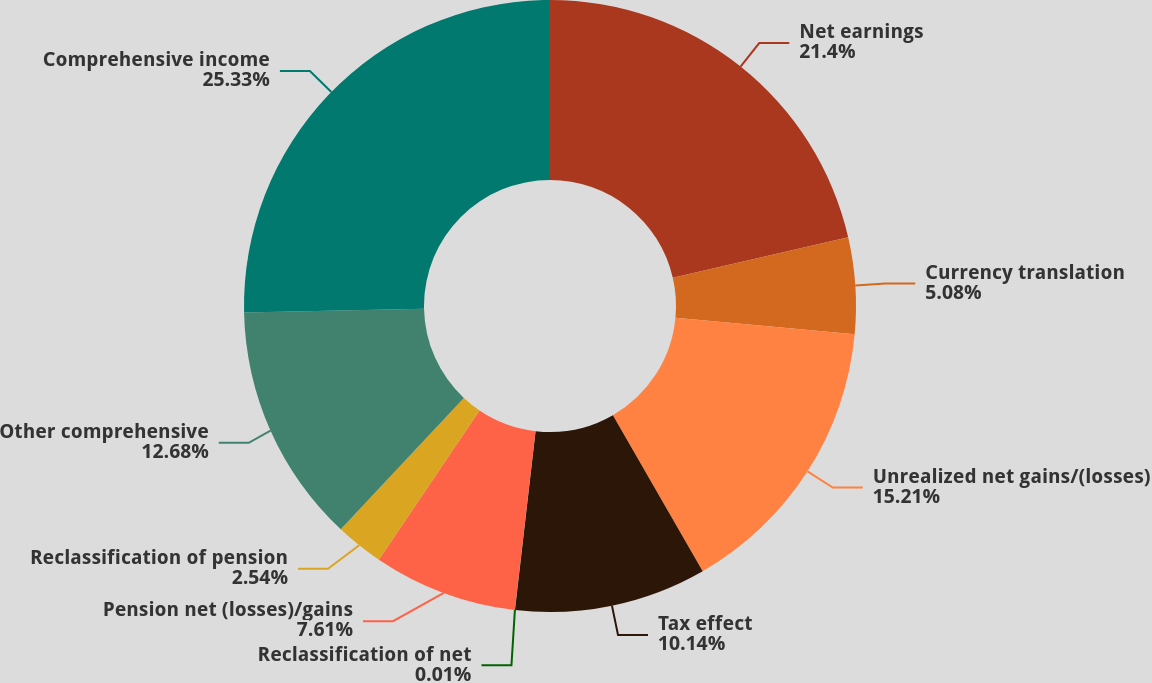<chart> <loc_0><loc_0><loc_500><loc_500><pie_chart><fcel>Net earnings<fcel>Currency translation<fcel>Unrealized net gains/(losses)<fcel>Tax effect<fcel>Reclassification of net<fcel>Pension net (losses)/gains<fcel>Reclassification of pension<fcel>Other comprehensive<fcel>Comprehensive income<nl><fcel>21.4%<fcel>5.08%<fcel>15.21%<fcel>10.14%<fcel>0.01%<fcel>7.61%<fcel>2.54%<fcel>12.68%<fcel>25.34%<nl></chart> 